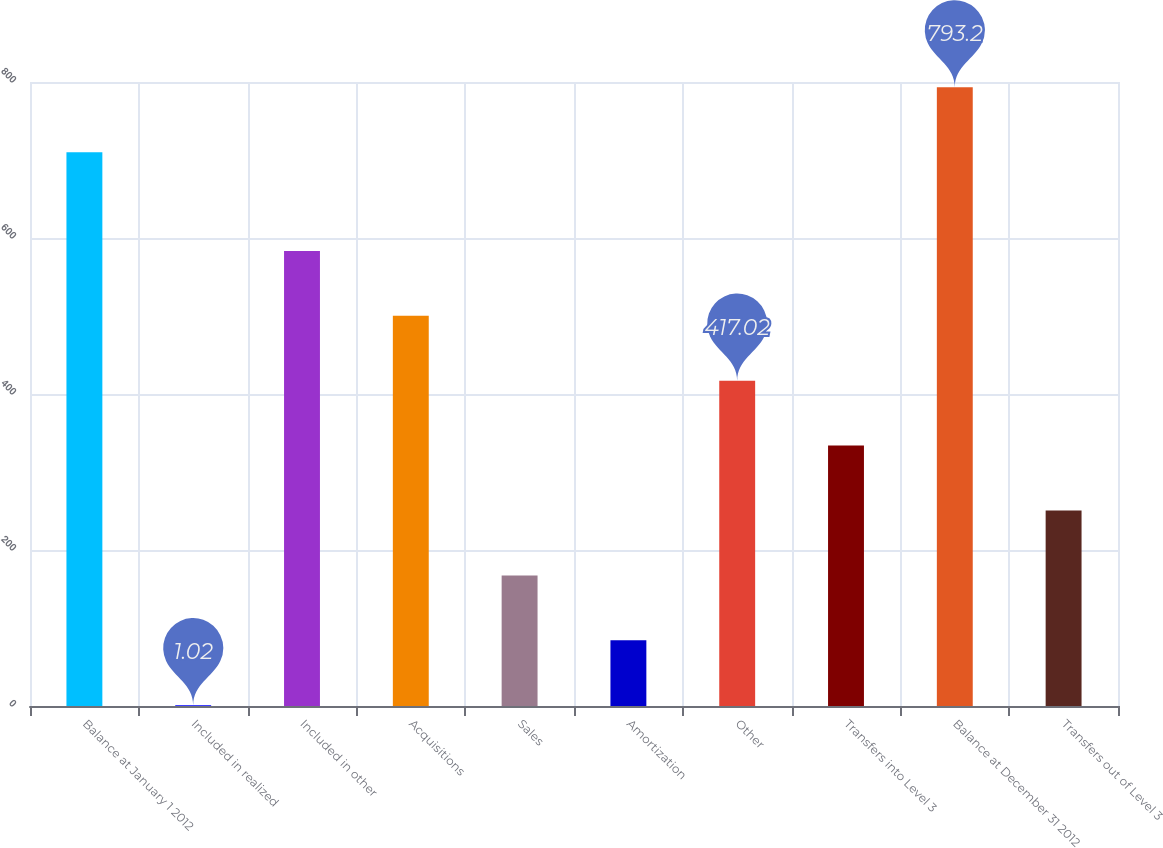Convert chart to OTSL. <chart><loc_0><loc_0><loc_500><loc_500><bar_chart><fcel>Balance at January 1 2012<fcel>Included in realized<fcel>Included in other<fcel>Acquisitions<fcel>Sales<fcel>Amortization<fcel>Other<fcel>Transfers into Level 3<fcel>Balance at December 31 2012<fcel>Transfers out of Level 3<nl><fcel>710<fcel>1.02<fcel>583.42<fcel>500.22<fcel>167.42<fcel>84.22<fcel>417.02<fcel>333.82<fcel>793.2<fcel>250.62<nl></chart> 